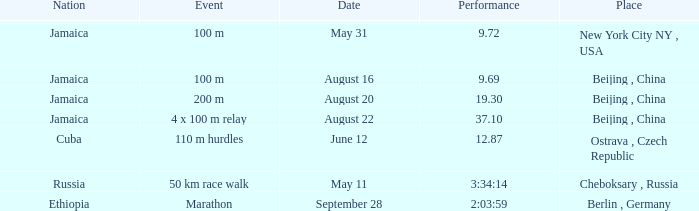What is the Place associated with Cuba? Ostrava , Czech Republic. 